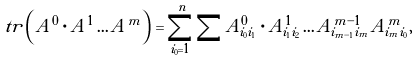Convert formula to latex. <formula><loc_0><loc_0><loc_500><loc_500>\ t r \left ( A ^ { 0 } \cdot A ^ { 1 } \dots A ^ { m } \right ) = \sum ^ { n } _ { i _ { 0 } = 1 } \sum A ^ { 0 } _ { i _ { 0 } i _ { 1 } } \cdot A ^ { 1 } _ { i _ { 1 } i _ { 2 } } \dots A ^ { m - 1 } _ { i _ { m - 1 } i _ { m } } A ^ { m } _ { i _ { m } i _ { 0 } } ,</formula> 